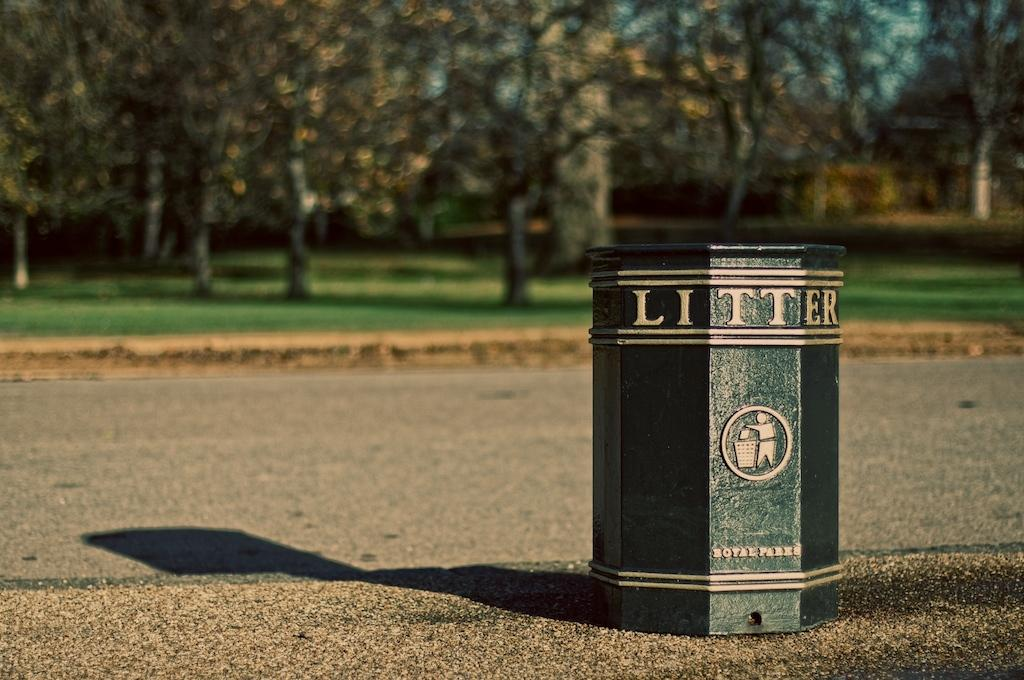<image>
Summarize the visual content of the image. A litter bin has a little icon of someone throwing trash away on it. 